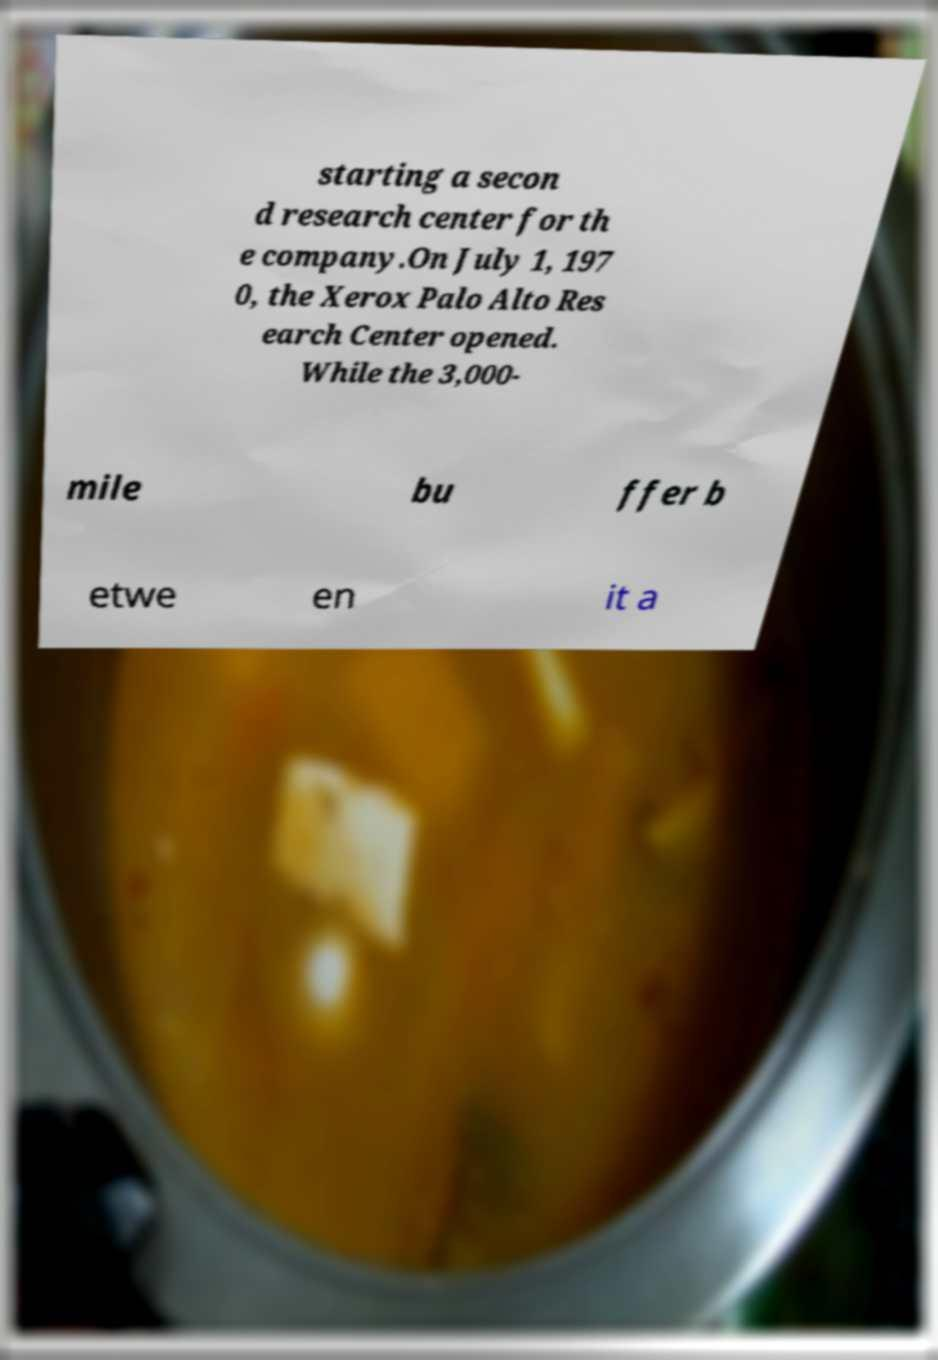I need the written content from this picture converted into text. Can you do that? starting a secon d research center for th e company.On July 1, 197 0, the Xerox Palo Alto Res earch Center opened. While the 3,000- mile bu ffer b etwe en it a 